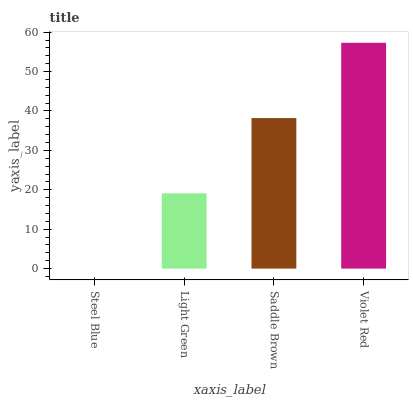Is Steel Blue the minimum?
Answer yes or no. Yes. Is Violet Red the maximum?
Answer yes or no. Yes. Is Light Green the minimum?
Answer yes or no. No. Is Light Green the maximum?
Answer yes or no. No. Is Light Green greater than Steel Blue?
Answer yes or no. Yes. Is Steel Blue less than Light Green?
Answer yes or no. Yes. Is Steel Blue greater than Light Green?
Answer yes or no. No. Is Light Green less than Steel Blue?
Answer yes or no. No. Is Saddle Brown the high median?
Answer yes or no. Yes. Is Light Green the low median?
Answer yes or no. Yes. Is Steel Blue the high median?
Answer yes or no. No. Is Violet Red the low median?
Answer yes or no. No. 